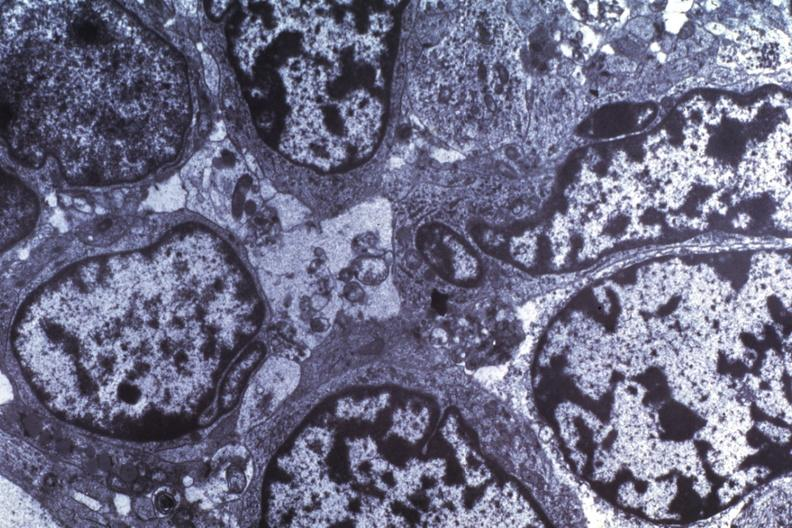does bilobed show dr garcia tumors 63?
Answer the question using a single word or phrase. No 